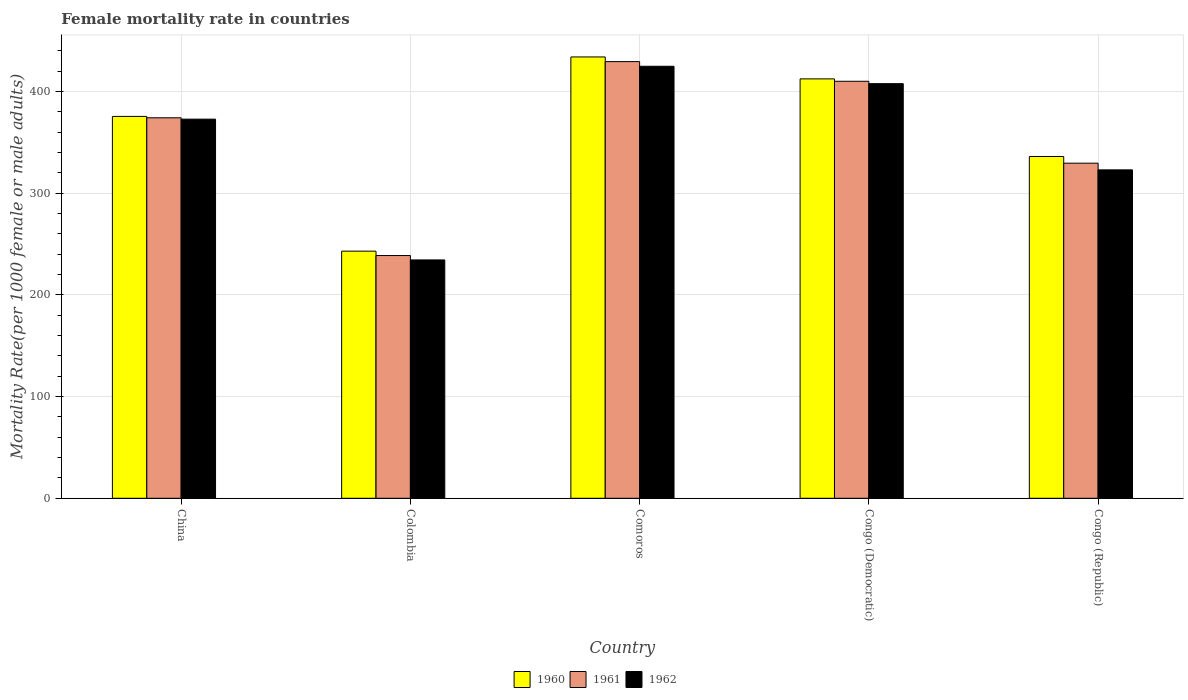Are the number of bars on each tick of the X-axis equal?
Give a very brief answer. Yes. What is the label of the 2nd group of bars from the left?
Make the answer very short. Colombia. What is the female mortality rate in 1962 in Congo (Republic)?
Offer a terse response. 323.07. Across all countries, what is the maximum female mortality rate in 1960?
Your answer should be very brief. 434.15. Across all countries, what is the minimum female mortality rate in 1960?
Give a very brief answer. 243.11. In which country was the female mortality rate in 1961 maximum?
Keep it short and to the point. Comoros. In which country was the female mortality rate in 1961 minimum?
Give a very brief answer. Colombia. What is the total female mortality rate in 1961 in the graph?
Make the answer very short. 1782.52. What is the difference between the female mortality rate in 1961 in Colombia and that in Congo (Democratic)?
Ensure brevity in your answer.  -171.42. What is the difference between the female mortality rate in 1962 in Comoros and the female mortality rate in 1961 in China?
Offer a very short reply. 50.67. What is the average female mortality rate in 1962 per country?
Offer a terse response. 352.67. What is the difference between the female mortality rate of/in 1962 and female mortality rate of/in 1960 in Congo (Democratic)?
Your answer should be very brief. -4.7. In how many countries, is the female mortality rate in 1960 greater than 360?
Your response must be concise. 3. What is the ratio of the female mortality rate in 1961 in China to that in Comoros?
Your answer should be compact. 0.87. Is the female mortality rate in 1961 in Comoros less than that in Congo (Republic)?
Give a very brief answer. No. Is the difference between the female mortality rate in 1962 in China and Colombia greater than the difference between the female mortality rate in 1960 in China and Colombia?
Your answer should be compact. Yes. What is the difference between the highest and the second highest female mortality rate in 1962?
Make the answer very short. 52.02. What is the difference between the highest and the lowest female mortality rate in 1961?
Your response must be concise. 190.77. In how many countries, is the female mortality rate in 1962 greater than the average female mortality rate in 1962 taken over all countries?
Provide a short and direct response. 3. Is the sum of the female mortality rate in 1962 in Comoros and Congo (Republic) greater than the maximum female mortality rate in 1961 across all countries?
Give a very brief answer. Yes. What does the 1st bar from the left in China represents?
Offer a very short reply. 1960. What does the 3rd bar from the right in China represents?
Provide a short and direct response. 1960. Is it the case that in every country, the sum of the female mortality rate in 1961 and female mortality rate in 1962 is greater than the female mortality rate in 1960?
Provide a short and direct response. Yes. Are all the bars in the graph horizontal?
Give a very brief answer. No. How many countries are there in the graph?
Your answer should be very brief. 5. Does the graph contain any zero values?
Your response must be concise. No. Does the graph contain grids?
Provide a short and direct response. Yes. How many legend labels are there?
Provide a succinct answer. 3. How are the legend labels stacked?
Provide a short and direct response. Horizontal. What is the title of the graph?
Your response must be concise. Female mortality rate in countries. Does "1964" appear as one of the legend labels in the graph?
Offer a very short reply. No. What is the label or title of the Y-axis?
Offer a terse response. Mortality Rate(per 1000 female or male adults). What is the Mortality Rate(per 1000 female or male adults) in 1960 in China?
Make the answer very short. 375.65. What is the Mortality Rate(per 1000 female or male adults) in 1961 in China?
Your answer should be compact. 374.3. What is the Mortality Rate(per 1000 female or male adults) in 1962 in China?
Ensure brevity in your answer.  372.96. What is the Mortality Rate(per 1000 female or male adults) of 1960 in Colombia?
Provide a short and direct response. 243.11. What is the Mortality Rate(per 1000 female or male adults) in 1961 in Colombia?
Make the answer very short. 238.79. What is the Mortality Rate(per 1000 female or male adults) of 1962 in Colombia?
Give a very brief answer. 234.47. What is the Mortality Rate(per 1000 female or male adults) in 1960 in Comoros?
Provide a succinct answer. 434.15. What is the Mortality Rate(per 1000 female or male adults) of 1961 in Comoros?
Your answer should be compact. 429.56. What is the Mortality Rate(per 1000 female or male adults) of 1962 in Comoros?
Make the answer very short. 424.98. What is the Mortality Rate(per 1000 female or male adults) in 1960 in Congo (Democratic)?
Ensure brevity in your answer.  412.56. What is the Mortality Rate(per 1000 female or male adults) of 1961 in Congo (Democratic)?
Offer a very short reply. 410.21. What is the Mortality Rate(per 1000 female or male adults) of 1962 in Congo (Democratic)?
Provide a short and direct response. 407.86. What is the Mortality Rate(per 1000 female or male adults) of 1960 in Congo (Republic)?
Ensure brevity in your answer.  336.22. What is the Mortality Rate(per 1000 female or male adults) in 1961 in Congo (Republic)?
Provide a succinct answer. 329.65. What is the Mortality Rate(per 1000 female or male adults) in 1962 in Congo (Republic)?
Your answer should be compact. 323.07. Across all countries, what is the maximum Mortality Rate(per 1000 female or male adults) of 1960?
Your response must be concise. 434.15. Across all countries, what is the maximum Mortality Rate(per 1000 female or male adults) in 1961?
Give a very brief answer. 429.56. Across all countries, what is the maximum Mortality Rate(per 1000 female or male adults) of 1962?
Provide a succinct answer. 424.98. Across all countries, what is the minimum Mortality Rate(per 1000 female or male adults) of 1960?
Keep it short and to the point. 243.11. Across all countries, what is the minimum Mortality Rate(per 1000 female or male adults) of 1961?
Make the answer very short. 238.79. Across all countries, what is the minimum Mortality Rate(per 1000 female or male adults) of 1962?
Your answer should be very brief. 234.47. What is the total Mortality Rate(per 1000 female or male adults) in 1960 in the graph?
Your answer should be compact. 1801.7. What is the total Mortality Rate(per 1000 female or male adults) of 1961 in the graph?
Ensure brevity in your answer.  1782.52. What is the total Mortality Rate(per 1000 female or male adults) of 1962 in the graph?
Make the answer very short. 1763.34. What is the difference between the Mortality Rate(per 1000 female or male adults) of 1960 in China and that in Colombia?
Provide a short and direct response. 132.54. What is the difference between the Mortality Rate(per 1000 female or male adults) in 1961 in China and that in Colombia?
Offer a terse response. 135.51. What is the difference between the Mortality Rate(per 1000 female or male adults) of 1962 in China and that in Colombia?
Provide a short and direct response. 138.48. What is the difference between the Mortality Rate(per 1000 female or male adults) of 1960 in China and that in Comoros?
Provide a succinct answer. -58.5. What is the difference between the Mortality Rate(per 1000 female or male adults) of 1961 in China and that in Comoros?
Your answer should be very brief. -55.26. What is the difference between the Mortality Rate(per 1000 female or male adults) of 1962 in China and that in Comoros?
Your answer should be compact. -52.02. What is the difference between the Mortality Rate(per 1000 female or male adults) in 1960 in China and that in Congo (Democratic)?
Provide a short and direct response. -36.92. What is the difference between the Mortality Rate(per 1000 female or male adults) of 1961 in China and that in Congo (Democratic)?
Make the answer very short. -35.91. What is the difference between the Mortality Rate(per 1000 female or male adults) of 1962 in China and that in Congo (Democratic)?
Provide a succinct answer. -34.9. What is the difference between the Mortality Rate(per 1000 female or male adults) in 1960 in China and that in Congo (Republic)?
Give a very brief answer. 39.42. What is the difference between the Mortality Rate(per 1000 female or male adults) in 1961 in China and that in Congo (Republic)?
Provide a succinct answer. 44.66. What is the difference between the Mortality Rate(per 1000 female or male adults) in 1962 in China and that in Congo (Republic)?
Provide a short and direct response. 49.89. What is the difference between the Mortality Rate(per 1000 female or male adults) in 1960 in Colombia and that in Comoros?
Your response must be concise. -191.04. What is the difference between the Mortality Rate(per 1000 female or male adults) of 1961 in Colombia and that in Comoros?
Offer a very short reply. -190.77. What is the difference between the Mortality Rate(per 1000 female or male adults) in 1962 in Colombia and that in Comoros?
Give a very brief answer. -190.5. What is the difference between the Mortality Rate(per 1000 female or male adults) of 1960 in Colombia and that in Congo (Democratic)?
Offer a terse response. -169.45. What is the difference between the Mortality Rate(per 1000 female or male adults) of 1961 in Colombia and that in Congo (Democratic)?
Provide a succinct answer. -171.42. What is the difference between the Mortality Rate(per 1000 female or male adults) in 1962 in Colombia and that in Congo (Democratic)?
Your response must be concise. -173.39. What is the difference between the Mortality Rate(per 1000 female or male adults) in 1960 in Colombia and that in Congo (Republic)?
Keep it short and to the point. -93.11. What is the difference between the Mortality Rate(per 1000 female or male adults) of 1961 in Colombia and that in Congo (Republic)?
Offer a very short reply. -90.85. What is the difference between the Mortality Rate(per 1000 female or male adults) of 1962 in Colombia and that in Congo (Republic)?
Ensure brevity in your answer.  -88.59. What is the difference between the Mortality Rate(per 1000 female or male adults) of 1960 in Comoros and that in Congo (Democratic)?
Your answer should be very brief. 21.59. What is the difference between the Mortality Rate(per 1000 female or male adults) in 1961 in Comoros and that in Congo (Democratic)?
Provide a short and direct response. 19.35. What is the difference between the Mortality Rate(per 1000 female or male adults) of 1962 in Comoros and that in Congo (Democratic)?
Make the answer very short. 17.12. What is the difference between the Mortality Rate(per 1000 female or male adults) in 1960 in Comoros and that in Congo (Republic)?
Ensure brevity in your answer.  97.93. What is the difference between the Mortality Rate(per 1000 female or male adults) of 1961 in Comoros and that in Congo (Republic)?
Offer a very short reply. 99.92. What is the difference between the Mortality Rate(per 1000 female or male adults) in 1962 in Comoros and that in Congo (Republic)?
Give a very brief answer. 101.91. What is the difference between the Mortality Rate(per 1000 female or male adults) of 1960 in Congo (Democratic) and that in Congo (Republic)?
Your response must be concise. 76.34. What is the difference between the Mortality Rate(per 1000 female or male adults) in 1961 in Congo (Democratic) and that in Congo (Republic)?
Provide a short and direct response. 80.57. What is the difference between the Mortality Rate(per 1000 female or male adults) in 1962 in Congo (Democratic) and that in Congo (Republic)?
Keep it short and to the point. 84.79. What is the difference between the Mortality Rate(per 1000 female or male adults) in 1960 in China and the Mortality Rate(per 1000 female or male adults) in 1961 in Colombia?
Ensure brevity in your answer.  136.86. What is the difference between the Mortality Rate(per 1000 female or male adults) in 1960 in China and the Mortality Rate(per 1000 female or male adults) in 1962 in Colombia?
Give a very brief answer. 141.17. What is the difference between the Mortality Rate(per 1000 female or male adults) of 1961 in China and the Mortality Rate(per 1000 female or male adults) of 1962 in Colombia?
Your response must be concise. 139.83. What is the difference between the Mortality Rate(per 1000 female or male adults) of 1960 in China and the Mortality Rate(per 1000 female or male adults) of 1961 in Comoros?
Your answer should be compact. -53.92. What is the difference between the Mortality Rate(per 1000 female or male adults) of 1960 in China and the Mortality Rate(per 1000 female or male adults) of 1962 in Comoros?
Provide a short and direct response. -49.33. What is the difference between the Mortality Rate(per 1000 female or male adults) of 1961 in China and the Mortality Rate(per 1000 female or male adults) of 1962 in Comoros?
Offer a very short reply. -50.67. What is the difference between the Mortality Rate(per 1000 female or male adults) of 1960 in China and the Mortality Rate(per 1000 female or male adults) of 1961 in Congo (Democratic)?
Provide a succinct answer. -34.56. What is the difference between the Mortality Rate(per 1000 female or male adults) in 1960 in China and the Mortality Rate(per 1000 female or male adults) in 1962 in Congo (Democratic)?
Make the answer very short. -32.21. What is the difference between the Mortality Rate(per 1000 female or male adults) in 1961 in China and the Mortality Rate(per 1000 female or male adults) in 1962 in Congo (Democratic)?
Offer a very short reply. -33.56. What is the difference between the Mortality Rate(per 1000 female or male adults) of 1960 in China and the Mortality Rate(per 1000 female or male adults) of 1961 in Congo (Republic)?
Provide a short and direct response. 46. What is the difference between the Mortality Rate(per 1000 female or male adults) in 1960 in China and the Mortality Rate(per 1000 female or male adults) in 1962 in Congo (Republic)?
Offer a terse response. 52.58. What is the difference between the Mortality Rate(per 1000 female or male adults) of 1961 in China and the Mortality Rate(per 1000 female or male adults) of 1962 in Congo (Republic)?
Provide a short and direct response. 51.23. What is the difference between the Mortality Rate(per 1000 female or male adults) of 1960 in Colombia and the Mortality Rate(per 1000 female or male adults) of 1961 in Comoros?
Provide a succinct answer. -186.46. What is the difference between the Mortality Rate(per 1000 female or male adults) of 1960 in Colombia and the Mortality Rate(per 1000 female or male adults) of 1962 in Comoros?
Provide a short and direct response. -181.87. What is the difference between the Mortality Rate(per 1000 female or male adults) of 1961 in Colombia and the Mortality Rate(per 1000 female or male adults) of 1962 in Comoros?
Offer a terse response. -186.19. What is the difference between the Mortality Rate(per 1000 female or male adults) in 1960 in Colombia and the Mortality Rate(per 1000 female or male adults) in 1961 in Congo (Democratic)?
Your answer should be compact. -167.1. What is the difference between the Mortality Rate(per 1000 female or male adults) of 1960 in Colombia and the Mortality Rate(per 1000 female or male adults) of 1962 in Congo (Democratic)?
Your answer should be very brief. -164.75. What is the difference between the Mortality Rate(per 1000 female or male adults) in 1961 in Colombia and the Mortality Rate(per 1000 female or male adults) in 1962 in Congo (Democratic)?
Ensure brevity in your answer.  -169.07. What is the difference between the Mortality Rate(per 1000 female or male adults) in 1960 in Colombia and the Mortality Rate(per 1000 female or male adults) in 1961 in Congo (Republic)?
Your answer should be very brief. -86.54. What is the difference between the Mortality Rate(per 1000 female or male adults) in 1960 in Colombia and the Mortality Rate(per 1000 female or male adults) in 1962 in Congo (Republic)?
Provide a succinct answer. -79.96. What is the difference between the Mortality Rate(per 1000 female or male adults) of 1961 in Colombia and the Mortality Rate(per 1000 female or male adults) of 1962 in Congo (Republic)?
Keep it short and to the point. -84.28. What is the difference between the Mortality Rate(per 1000 female or male adults) of 1960 in Comoros and the Mortality Rate(per 1000 female or male adults) of 1961 in Congo (Democratic)?
Your response must be concise. 23.94. What is the difference between the Mortality Rate(per 1000 female or male adults) of 1960 in Comoros and the Mortality Rate(per 1000 female or male adults) of 1962 in Congo (Democratic)?
Your answer should be compact. 26.29. What is the difference between the Mortality Rate(per 1000 female or male adults) in 1961 in Comoros and the Mortality Rate(per 1000 female or male adults) in 1962 in Congo (Democratic)?
Your answer should be very brief. 21.7. What is the difference between the Mortality Rate(per 1000 female or male adults) of 1960 in Comoros and the Mortality Rate(per 1000 female or male adults) of 1961 in Congo (Republic)?
Keep it short and to the point. 104.51. What is the difference between the Mortality Rate(per 1000 female or male adults) in 1960 in Comoros and the Mortality Rate(per 1000 female or male adults) in 1962 in Congo (Republic)?
Keep it short and to the point. 111.08. What is the difference between the Mortality Rate(per 1000 female or male adults) in 1961 in Comoros and the Mortality Rate(per 1000 female or male adults) in 1962 in Congo (Republic)?
Keep it short and to the point. 106.5. What is the difference between the Mortality Rate(per 1000 female or male adults) of 1960 in Congo (Democratic) and the Mortality Rate(per 1000 female or male adults) of 1961 in Congo (Republic)?
Your answer should be compact. 82.92. What is the difference between the Mortality Rate(per 1000 female or male adults) in 1960 in Congo (Democratic) and the Mortality Rate(per 1000 female or male adults) in 1962 in Congo (Republic)?
Provide a succinct answer. 89.49. What is the difference between the Mortality Rate(per 1000 female or male adults) in 1961 in Congo (Democratic) and the Mortality Rate(per 1000 female or male adults) in 1962 in Congo (Republic)?
Give a very brief answer. 87.14. What is the average Mortality Rate(per 1000 female or male adults) of 1960 per country?
Give a very brief answer. 360.34. What is the average Mortality Rate(per 1000 female or male adults) of 1961 per country?
Keep it short and to the point. 356.5. What is the average Mortality Rate(per 1000 female or male adults) in 1962 per country?
Keep it short and to the point. 352.67. What is the difference between the Mortality Rate(per 1000 female or male adults) in 1960 and Mortality Rate(per 1000 female or male adults) in 1961 in China?
Your answer should be compact. 1.34. What is the difference between the Mortality Rate(per 1000 female or male adults) in 1960 and Mortality Rate(per 1000 female or male adults) in 1962 in China?
Provide a short and direct response. 2.69. What is the difference between the Mortality Rate(per 1000 female or male adults) in 1961 and Mortality Rate(per 1000 female or male adults) in 1962 in China?
Offer a terse response. 1.34. What is the difference between the Mortality Rate(per 1000 female or male adults) of 1960 and Mortality Rate(per 1000 female or male adults) of 1961 in Colombia?
Make the answer very short. 4.32. What is the difference between the Mortality Rate(per 1000 female or male adults) in 1960 and Mortality Rate(per 1000 female or male adults) in 1962 in Colombia?
Keep it short and to the point. 8.63. What is the difference between the Mortality Rate(per 1000 female or male adults) in 1961 and Mortality Rate(per 1000 female or male adults) in 1962 in Colombia?
Give a very brief answer. 4.32. What is the difference between the Mortality Rate(per 1000 female or male adults) in 1960 and Mortality Rate(per 1000 female or male adults) in 1961 in Comoros?
Your answer should be very brief. 4.59. What is the difference between the Mortality Rate(per 1000 female or male adults) of 1960 and Mortality Rate(per 1000 female or male adults) of 1962 in Comoros?
Give a very brief answer. 9.18. What is the difference between the Mortality Rate(per 1000 female or male adults) in 1961 and Mortality Rate(per 1000 female or male adults) in 1962 in Comoros?
Ensure brevity in your answer.  4.59. What is the difference between the Mortality Rate(per 1000 female or male adults) in 1960 and Mortality Rate(per 1000 female or male adults) in 1961 in Congo (Democratic)?
Your answer should be compact. 2.35. What is the difference between the Mortality Rate(per 1000 female or male adults) in 1960 and Mortality Rate(per 1000 female or male adults) in 1962 in Congo (Democratic)?
Ensure brevity in your answer.  4.7. What is the difference between the Mortality Rate(per 1000 female or male adults) of 1961 and Mortality Rate(per 1000 female or male adults) of 1962 in Congo (Democratic)?
Offer a terse response. 2.35. What is the difference between the Mortality Rate(per 1000 female or male adults) of 1960 and Mortality Rate(per 1000 female or male adults) of 1961 in Congo (Republic)?
Your answer should be compact. 6.58. What is the difference between the Mortality Rate(per 1000 female or male adults) of 1960 and Mortality Rate(per 1000 female or male adults) of 1962 in Congo (Republic)?
Offer a very short reply. 13.15. What is the difference between the Mortality Rate(per 1000 female or male adults) in 1961 and Mortality Rate(per 1000 female or male adults) in 1962 in Congo (Republic)?
Provide a succinct answer. 6.58. What is the ratio of the Mortality Rate(per 1000 female or male adults) in 1960 in China to that in Colombia?
Offer a terse response. 1.55. What is the ratio of the Mortality Rate(per 1000 female or male adults) of 1961 in China to that in Colombia?
Ensure brevity in your answer.  1.57. What is the ratio of the Mortality Rate(per 1000 female or male adults) of 1962 in China to that in Colombia?
Give a very brief answer. 1.59. What is the ratio of the Mortality Rate(per 1000 female or male adults) of 1960 in China to that in Comoros?
Your response must be concise. 0.87. What is the ratio of the Mortality Rate(per 1000 female or male adults) of 1961 in China to that in Comoros?
Ensure brevity in your answer.  0.87. What is the ratio of the Mortality Rate(per 1000 female or male adults) of 1962 in China to that in Comoros?
Keep it short and to the point. 0.88. What is the ratio of the Mortality Rate(per 1000 female or male adults) in 1960 in China to that in Congo (Democratic)?
Provide a short and direct response. 0.91. What is the ratio of the Mortality Rate(per 1000 female or male adults) of 1961 in China to that in Congo (Democratic)?
Ensure brevity in your answer.  0.91. What is the ratio of the Mortality Rate(per 1000 female or male adults) of 1962 in China to that in Congo (Democratic)?
Provide a succinct answer. 0.91. What is the ratio of the Mortality Rate(per 1000 female or male adults) in 1960 in China to that in Congo (Republic)?
Make the answer very short. 1.12. What is the ratio of the Mortality Rate(per 1000 female or male adults) of 1961 in China to that in Congo (Republic)?
Keep it short and to the point. 1.14. What is the ratio of the Mortality Rate(per 1000 female or male adults) in 1962 in China to that in Congo (Republic)?
Offer a very short reply. 1.15. What is the ratio of the Mortality Rate(per 1000 female or male adults) of 1960 in Colombia to that in Comoros?
Make the answer very short. 0.56. What is the ratio of the Mortality Rate(per 1000 female or male adults) of 1961 in Colombia to that in Comoros?
Your response must be concise. 0.56. What is the ratio of the Mortality Rate(per 1000 female or male adults) of 1962 in Colombia to that in Comoros?
Provide a succinct answer. 0.55. What is the ratio of the Mortality Rate(per 1000 female or male adults) of 1960 in Colombia to that in Congo (Democratic)?
Keep it short and to the point. 0.59. What is the ratio of the Mortality Rate(per 1000 female or male adults) of 1961 in Colombia to that in Congo (Democratic)?
Offer a terse response. 0.58. What is the ratio of the Mortality Rate(per 1000 female or male adults) in 1962 in Colombia to that in Congo (Democratic)?
Your answer should be compact. 0.57. What is the ratio of the Mortality Rate(per 1000 female or male adults) in 1960 in Colombia to that in Congo (Republic)?
Ensure brevity in your answer.  0.72. What is the ratio of the Mortality Rate(per 1000 female or male adults) of 1961 in Colombia to that in Congo (Republic)?
Provide a succinct answer. 0.72. What is the ratio of the Mortality Rate(per 1000 female or male adults) of 1962 in Colombia to that in Congo (Republic)?
Keep it short and to the point. 0.73. What is the ratio of the Mortality Rate(per 1000 female or male adults) of 1960 in Comoros to that in Congo (Democratic)?
Your answer should be compact. 1.05. What is the ratio of the Mortality Rate(per 1000 female or male adults) of 1961 in Comoros to that in Congo (Democratic)?
Offer a very short reply. 1.05. What is the ratio of the Mortality Rate(per 1000 female or male adults) in 1962 in Comoros to that in Congo (Democratic)?
Your answer should be very brief. 1.04. What is the ratio of the Mortality Rate(per 1000 female or male adults) of 1960 in Comoros to that in Congo (Republic)?
Your answer should be very brief. 1.29. What is the ratio of the Mortality Rate(per 1000 female or male adults) in 1961 in Comoros to that in Congo (Republic)?
Keep it short and to the point. 1.3. What is the ratio of the Mortality Rate(per 1000 female or male adults) of 1962 in Comoros to that in Congo (Republic)?
Make the answer very short. 1.32. What is the ratio of the Mortality Rate(per 1000 female or male adults) of 1960 in Congo (Democratic) to that in Congo (Republic)?
Your response must be concise. 1.23. What is the ratio of the Mortality Rate(per 1000 female or male adults) in 1961 in Congo (Democratic) to that in Congo (Republic)?
Offer a very short reply. 1.24. What is the ratio of the Mortality Rate(per 1000 female or male adults) in 1962 in Congo (Democratic) to that in Congo (Republic)?
Offer a terse response. 1.26. What is the difference between the highest and the second highest Mortality Rate(per 1000 female or male adults) of 1960?
Your answer should be very brief. 21.59. What is the difference between the highest and the second highest Mortality Rate(per 1000 female or male adults) of 1961?
Give a very brief answer. 19.35. What is the difference between the highest and the second highest Mortality Rate(per 1000 female or male adults) in 1962?
Make the answer very short. 17.12. What is the difference between the highest and the lowest Mortality Rate(per 1000 female or male adults) of 1960?
Make the answer very short. 191.04. What is the difference between the highest and the lowest Mortality Rate(per 1000 female or male adults) of 1961?
Give a very brief answer. 190.77. What is the difference between the highest and the lowest Mortality Rate(per 1000 female or male adults) in 1962?
Your response must be concise. 190.5. 